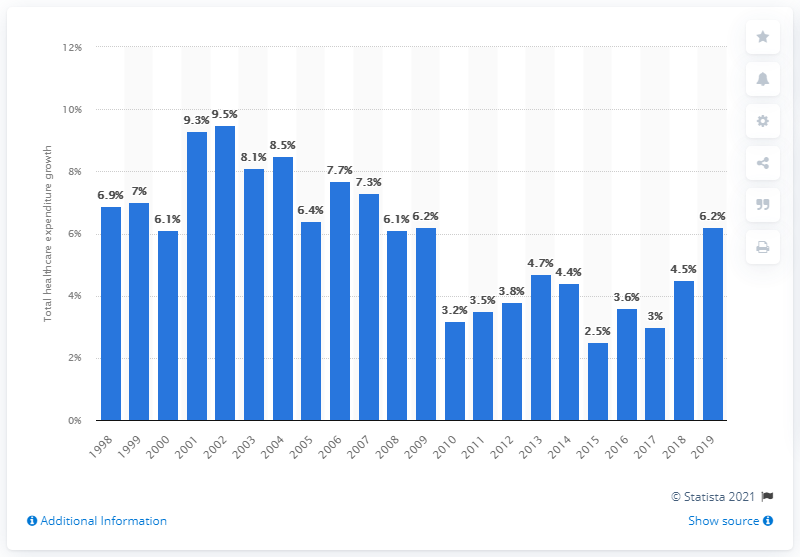Point out several critical features in this image. In the year 2002, the highest healthcare spending growth rate was recorded. The healthcare spending growth rate in the UK began to fluctuate in 1998. In 1998, the healthcare spending growth rate in the United Kingdom was 6.9%. 